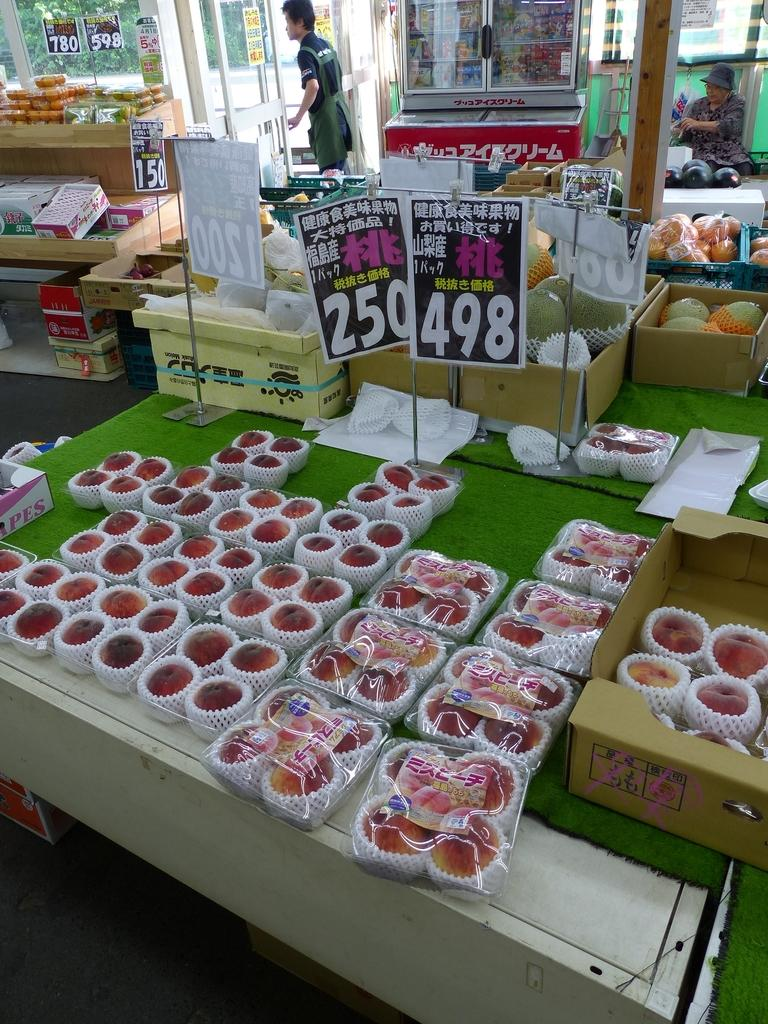<image>
Write a terse but informative summary of the picture. A sign with Chinese writing displaying 498 sitting on a table covered in green paper. 